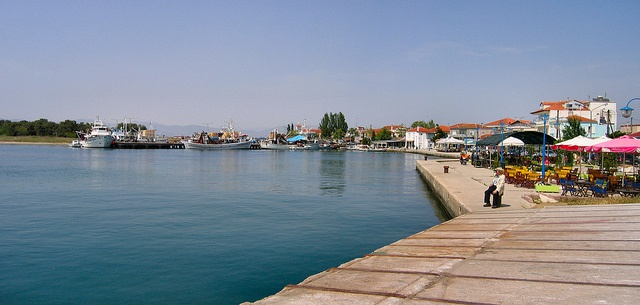Describe the objects in this image and their specific colors. I can see boat in darkgray, gray, and black tones, boat in darkgray, lightgray, gray, and black tones, umbrella in darkgray, white, brown, and black tones, umbrella in darkgray, lightpink, brown, and violet tones, and people in darkgray, black, beige, gray, and tan tones in this image. 